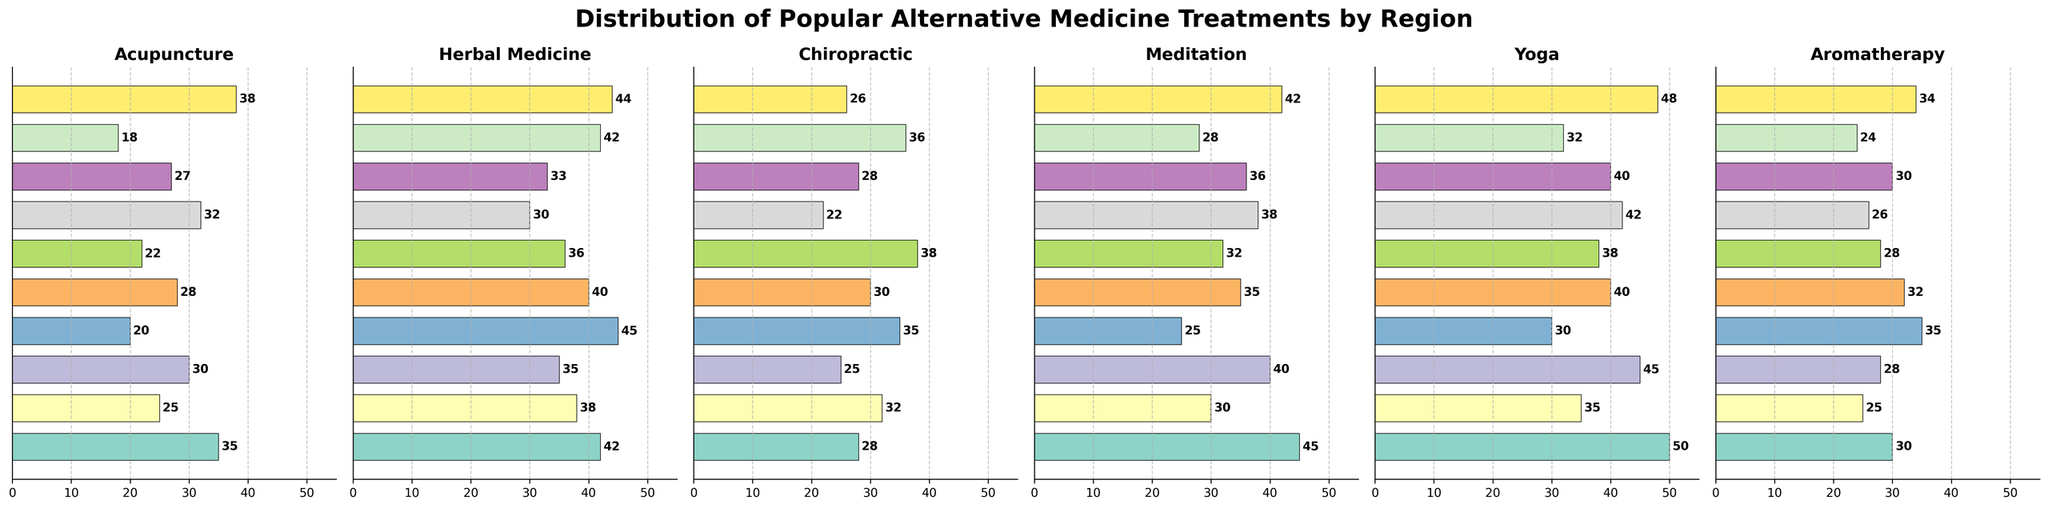Which region has the highest usage of Yoga? By examining the "Yoga" subplot, the bar with the longest length represents the highest usage. The West Coast has the highest usage of Yoga.
Answer: West Coast Which region has the lowest usage of Chiropractic? By examining the "Chiropractic" subplot, the shortest bar indicates the lowest usage. New England has the lowest usage of Chiropractic.
Answer: New England What is the total usage of Acupuncture in the West Coast and Pacific Northwest? Add the values from the "Acupuncture" axis for the West Coast (35) and Pacific Northwest (38). The sum is 35 + 38 = 73.
Answer: 73 Which treatment is the most popular in the Southeast? Check which bar extends the furthest for the Southeast region in each subplot. In the "Herbal Medicine" subplot, the bar for the Southeast extends to 45, showing the highest value.
Answer: Herbal Medicine How does the usage of meditation in the Northeast compare to the Rocky Mountains? In the "Meditation" subplot, the Northeast has a value of 40, while the Rocky Mountains has a value of 32. Since 40 > 32, the Northeast has higher usage of Meditation.
Answer: Northeast Which treatment shows the most consistent (least variation) usage across all regions? By scanning all subplots and comparing the lengths of the bars across regions, Yoga appears to have bars that are relatively close in length, indicating less variation.
Answer: Yoga What is the average usage of Aromatherapy across all regions? Sum the values of Aromatherapy for all regions (30 + 25 + 28 + 35 + 32 + 28 + 26 + 30 + 24 + 34) = 292. Divide this sum by the number of regions (10). 292 / 10 = 29.2.
Answer: 29.2 Which region has the highest combined usage of Herbal Medicine and Aromatherapy? Add the values for each region for both treatments and compare. For example, West Coast (42 + 30 = 72), Midwest (38 + 25 = 63), etc. The region with the highest combined value is the Southeast with 45 + 35 = 80.
Answer: Southeast How does the popularity of Herbal Medicine in the Midwest compare to the Southwest? In the "Herbal Medicine" subplot, the values for the Midwest and Southwest are 38 and 40, respectively. Since 38 < 40, Herbal Medicine is more popular in the Southwest.
Answer: Southwest 